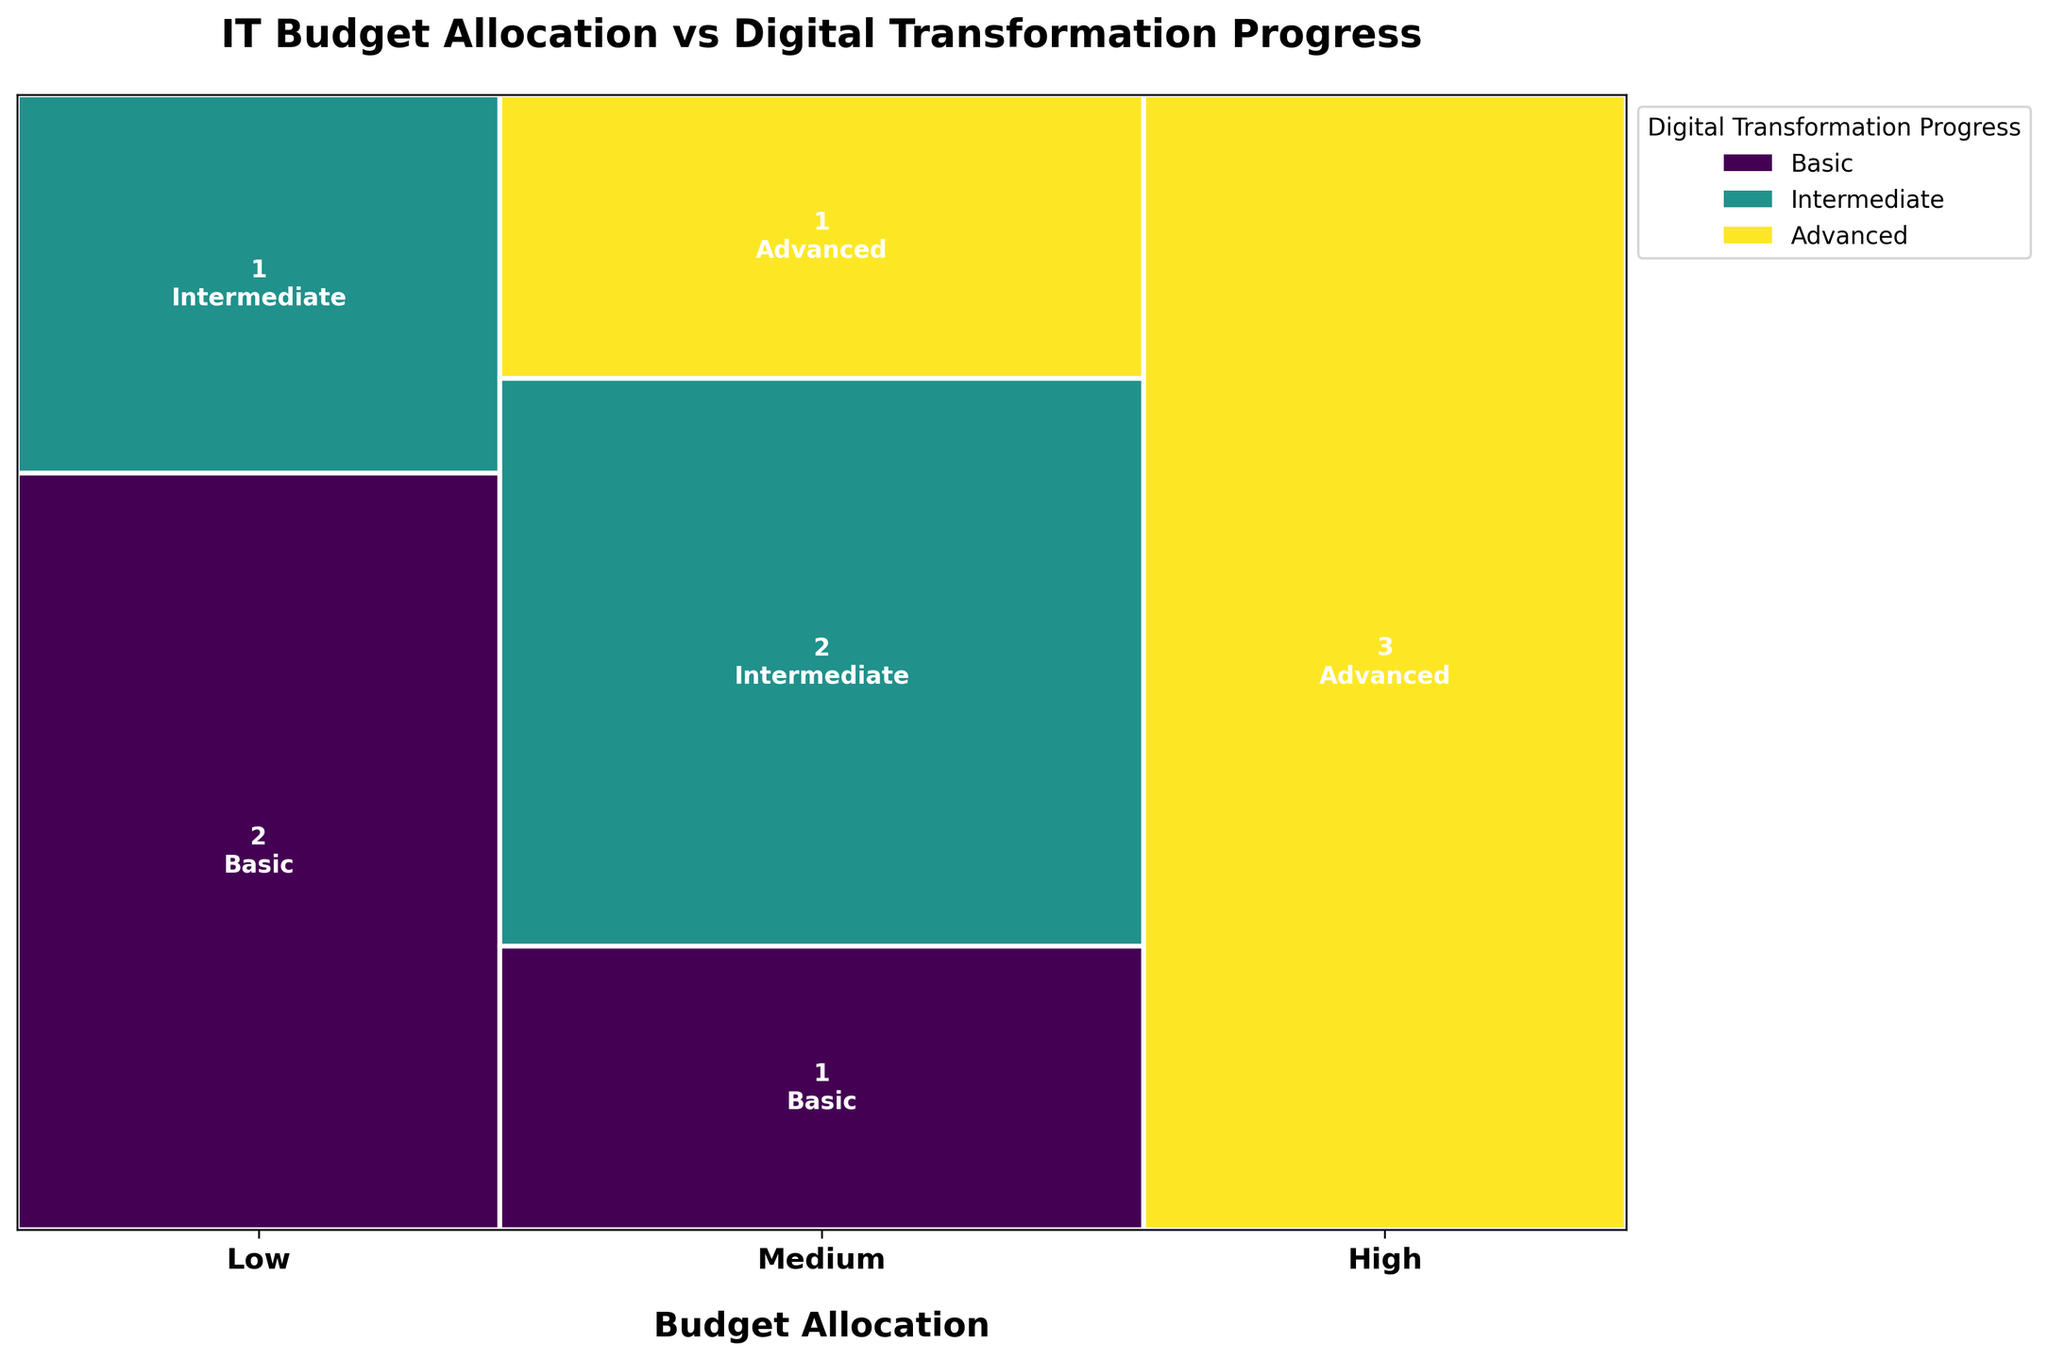How many sectors have a high level of budget allocation in the plot? To answer this, we need to look at the sections of the mosaic plot corresponding to "High" budget allocation and count the sectors. By observing the plot, we can easily determine the number of sectors in this category.
Answer: 3 Which digital transformation progress level has the most sectors with medium budget allocation? First, identify the sections corresponding to "Medium" budget allocation in the mosaic plot. Then, within this category, count the sections for "Basic", "Intermediate", and "Advanced" progress levels.
Answer: Intermediate How many sectors are in the "Advanced" digital transformation progress category across all budget allocations? To find this, we need to tally the sectors in the mosaic plot under the "Advanced" progress category within each budget allocation ("Low", "Medium", and "High").
Answer: 4 Compare the sizes of the sections for "Intermediate" progress with "Medium" budget allocation and "Intermediate" progress with "Low" budget allocation. Which is larger? To compare these, observe the sizes of the sections for the specified categories in the mosaic plot. The section with the most considerable area is the larger one.
Answer: Medium-Intermediate What is the ratio of sectors with "Basic" progress to those with "Advanced" progress? Count the number of sectors in the "Basic" progress category and the number of sectors in the "Advanced" progress category from the mosaic plot. Then, calculate the ratio of these counts by dividing the number of "Basic" sectors by the number of "Advanced" sectors.
Answer: 3:4 Does any section of the mosaic plot have no sectors represented? If so, which one? Look for areas in the mosaic plot that contain no sections or text labels. These areas represent combinations of budget allocation and digital transformation progress with no sectors. Identify the empty category.
Answer: Low-Advanced 